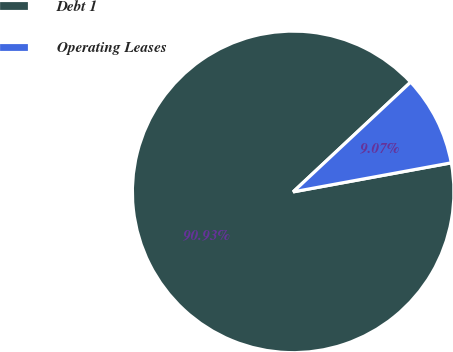Convert chart to OTSL. <chart><loc_0><loc_0><loc_500><loc_500><pie_chart><fcel>Debt 1<fcel>Operating Leases<nl><fcel>90.93%<fcel>9.07%<nl></chart> 